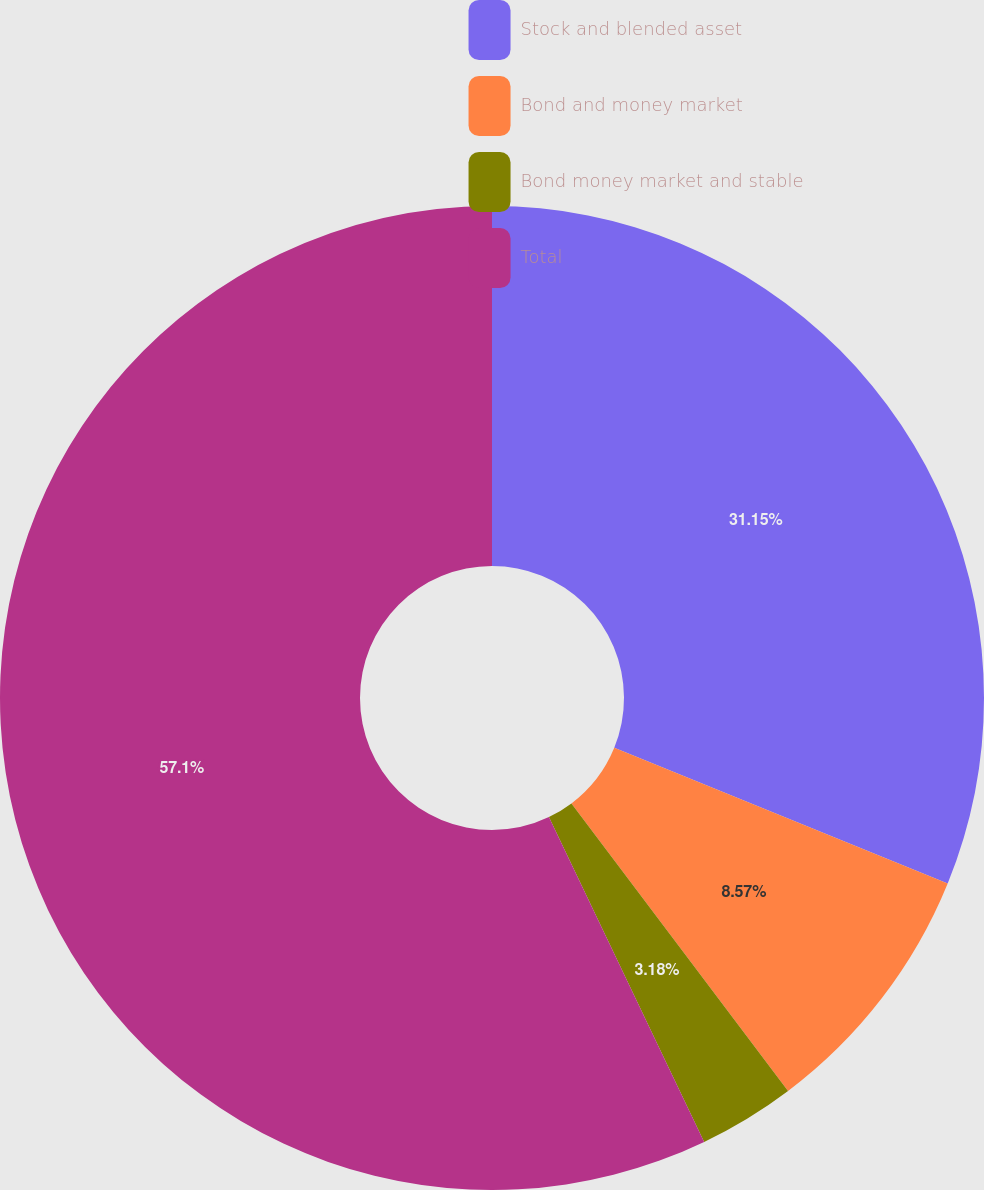<chart> <loc_0><loc_0><loc_500><loc_500><pie_chart><fcel>Stock and blended asset<fcel>Bond and money market<fcel>Bond money market and stable<fcel>Total<nl><fcel>31.15%<fcel>8.57%<fcel>3.18%<fcel>57.09%<nl></chart> 